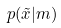Convert formula to latex. <formula><loc_0><loc_0><loc_500><loc_500>p ( \tilde { x } | m )</formula> 